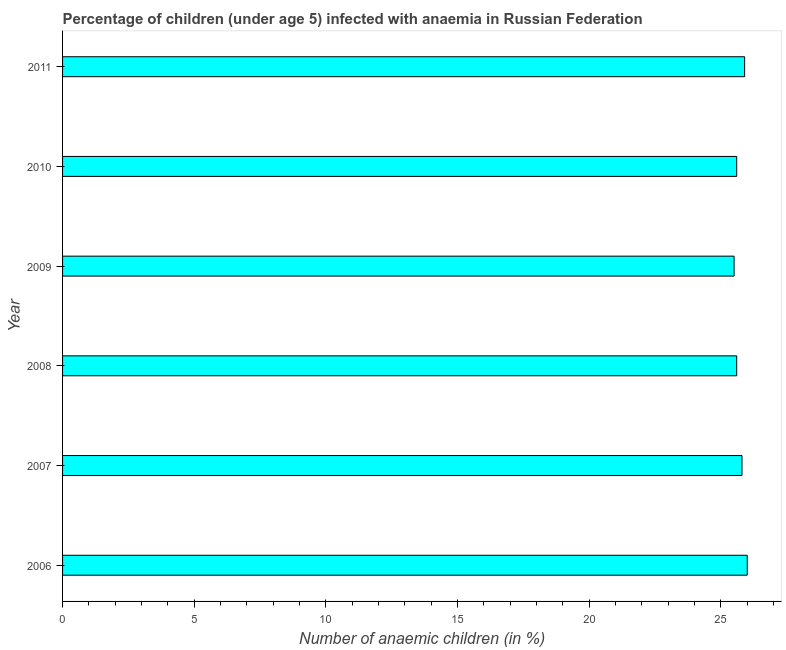What is the title of the graph?
Provide a short and direct response. Percentage of children (under age 5) infected with anaemia in Russian Federation. What is the label or title of the X-axis?
Provide a short and direct response. Number of anaemic children (in %). What is the number of anaemic children in 2006?
Make the answer very short. 26. Across all years, what is the maximum number of anaemic children?
Provide a succinct answer. 26. Across all years, what is the minimum number of anaemic children?
Provide a succinct answer. 25.5. What is the sum of the number of anaemic children?
Provide a short and direct response. 154.4. What is the difference between the number of anaemic children in 2007 and 2008?
Offer a terse response. 0.2. What is the average number of anaemic children per year?
Ensure brevity in your answer.  25.73. What is the median number of anaemic children?
Offer a terse response. 25.7. Do a majority of the years between 2008 and 2006 (inclusive) have number of anaemic children greater than 21 %?
Provide a succinct answer. Yes. Is the difference between the number of anaemic children in 2008 and 2010 greater than the difference between any two years?
Your answer should be compact. No. What is the difference between the highest and the second highest number of anaemic children?
Make the answer very short. 0.1. Is the sum of the number of anaemic children in 2006 and 2011 greater than the maximum number of anaemic children across all years?
Ensure brevity in your answer.  Yes. What is the difference between the highest and the lowest number of anaemic children?
Your answer should be very brief. 0.5. In how many years, is the number of anaemic children greater than the average number of anaemic children taken over all years?
Provide a succinct answer. 3. How many years are there in the graph?
Make the answer very short. 6. What is the difference between two consecutive major ticks on the X-axis?
Keep it short and to the point. 5. Are the values on the major ticks of X-axis written in scientific E-notation?
Provide a short and direct response. No. What is the Number of anaemic children (in %) in 2006?
Your answer should be very brief. 26. What is the Number of anaemic children (in %) in 2007?
Your answer should be very brief. 25.8. What is the Number of anaemic children (in %) of 2008?
Your answer should be very brief. 25.6. What is the Number of anaemic children (in %) in 2010?
Offer a very short reply. 25.6. What is the Number of anaemic children (in %) of 2011?
Provide a short and direct response. 25.9. What is the difference between the Number of anaemic children (in %) in 2006 and 2008?
Offer a terse response. 0.4. What is the difference between the Number of anaemic children (in %) in 2006 and 2009?
Provide a succinct answer. 0.5. What is the difference between the Number of anaemic children (in %) in 2006 and 2010?
Your response must be concise. 0.4. What is the difference between the Number of anaemic children (in %) in 2006 and 2011?
Your response must be concise. 0.1. What is the difference between the Number of anaemic children (in %) in 2007 and 2009?
Ensure brevity in your answer.  0.3. What is the difference between the Number of anaemic children (in %) in 2008 and 2010?
Your response must be concise. 0. What is the difference between the Number of anaemic children (in %) in 2009 and 2011?
Provide a succinct answer. -0.4. What is the ratio of the Number of anaemic children (in %) in 2006 to that in 2009?
Make the answer very short. 1.02. What is the ratio of the Number of anaemic children (in %) in 2007 to that in 2009?
Provide a succinct answer. 1.01. What is the ratio of the Number of anaemic children (in %) in 2007 to that in 2010?
Provide a short and direct response. 1.01. What is the ratio of the Number of anaemic children (in %) in 2007 to that in 2011?
Provide a short and direct response. 1. What is the ratio of the Number of anaemic children (in %) in 2008 to that in 2009?
Offer a terse response. 1. What is the ratio of the Number of anaemic children (in %) in 2008 to that in 2010?
Offer a very short reply. 1. What is the ratio of the Number of anaemic children (in %) in 2008 to that in 2011?
Provide a short and direct response. 0.99. What is the ratio of the Number of anaemic children (in %) in 2009 to that in 2011?
Ensure brevity in your answer.  0.98. What is the ratio of the Number of anaemic children (in %) in 2010 to that in 2011?
Your answer should be very brief. 0.99. 